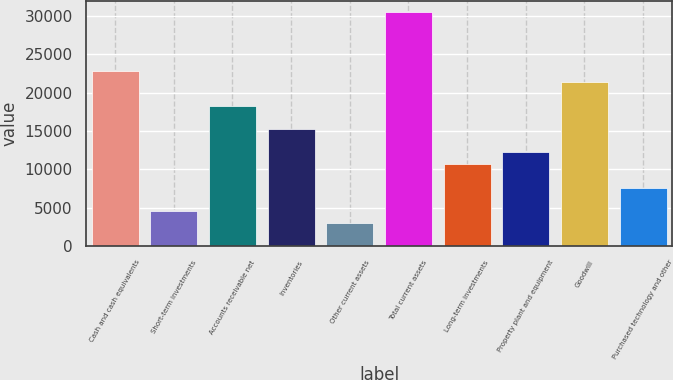<chart> <loc_0><loc_0><loc_500><loc_500><bar_chart><fcel>Cash and cash equivalents<fcel>Short-term investments<fcel>Accounts receivable net<fcel>Inventories<fcel>Other current assets<fcel>Total current assets<fcel>Long-term investments<fcel>Property plant and equipment<fcel>Goodwill<fcel>Purchased technology and other<nl><fcel>22872.5<fcel>4583.3<fcel>18300.2<fcel>15252<fcel>3059.2<fcel>30493<fcel>10679.7<fcel>12203.8<fcel>21348.4<fcel>7631.5<nl></chart> 